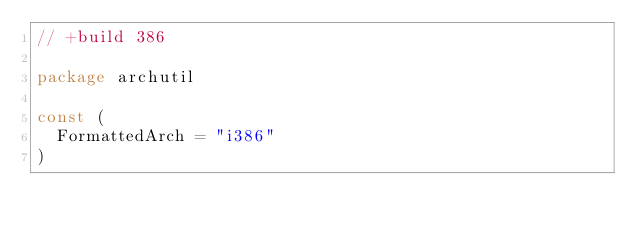Convert code to text. <code><loc_0><loc_0><loc_500><loc_500><_Go_>// +build 386

package archutil

const (
	FormattedArch = "i386"
)
</code> 